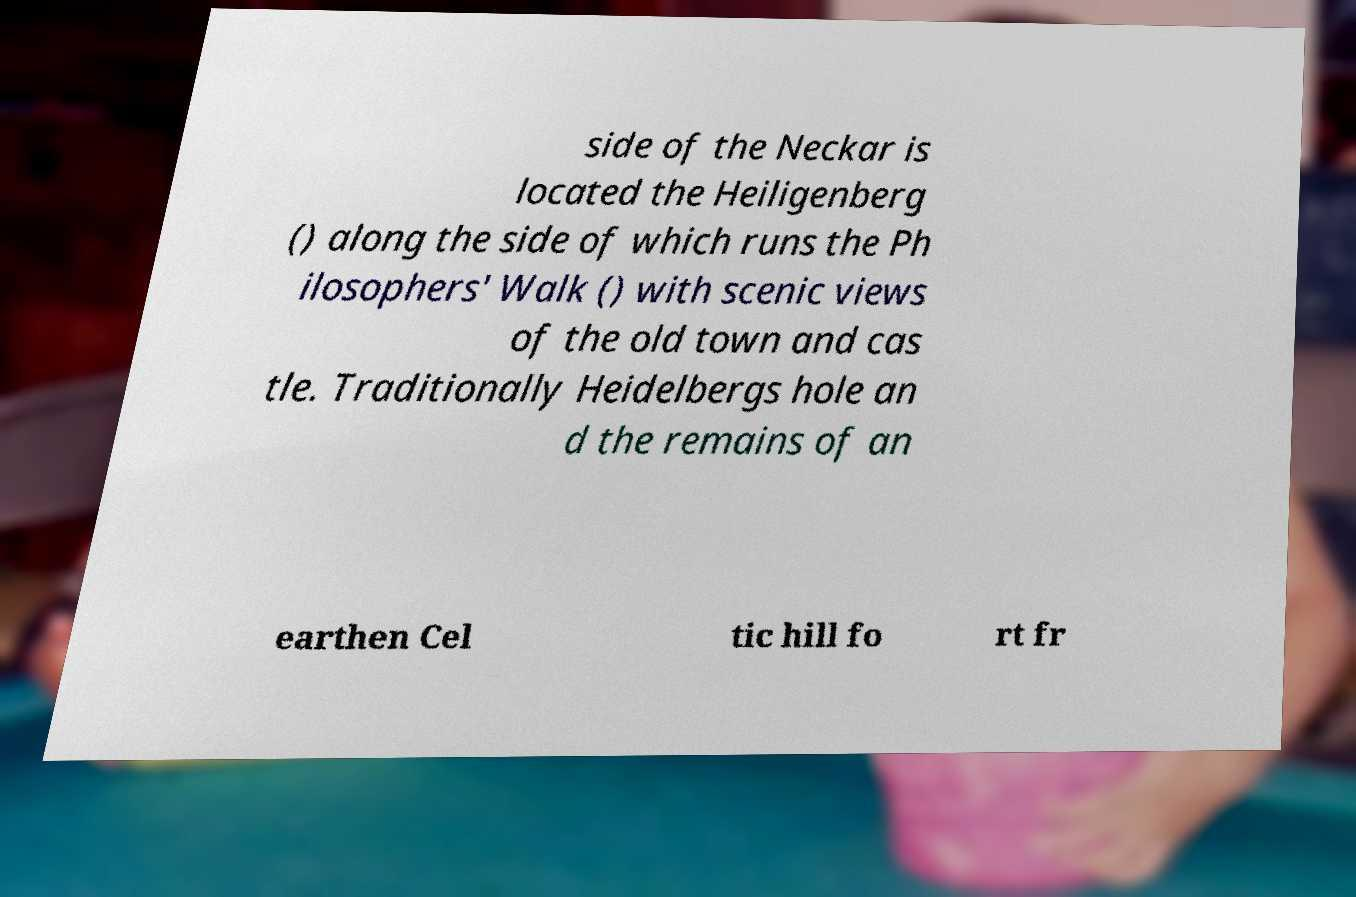What messages or text are displayed in this image? I need them in a readable, typed format. side of the Neckar is located the Heiligenberg () along the side of which runs the Ph ilosophers' Walk () with scenic views of the old town and cas tle. Traditionally Heidelbergs hole an d the remains of an earthen Cel tic hill fo rt fr 